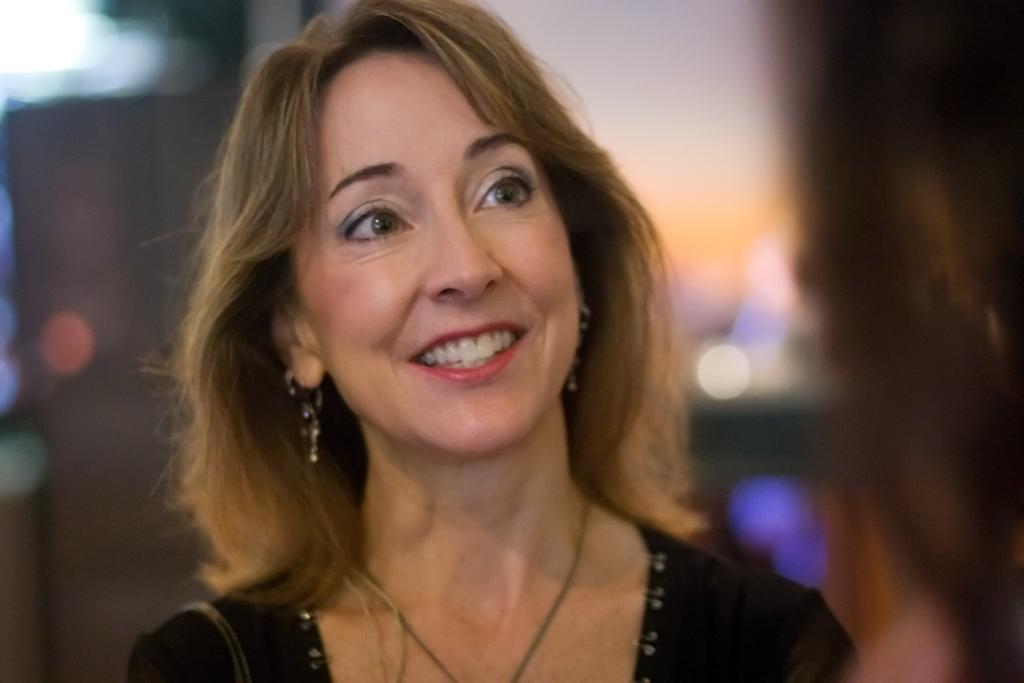Who is the main subject in the picture? There is a woman in the picture. What is the woman wearing? The woman is wearing a black dress. What expression does the woman have? The woman is smiling. In which direction is the woman looking? The woman is looking to the right side. What type of stitch is the woman using to sew a dinosaur in the image? There is no stitch or dinosaur present in the image; it features a woman wearing a black dress and smiling. 